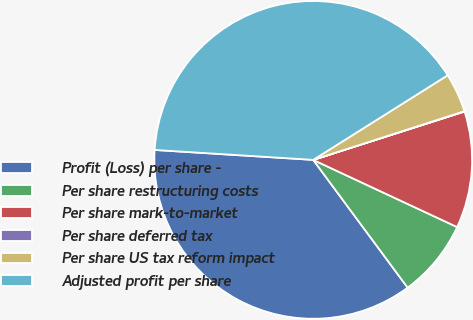<chart> <loc_0><loc_0><loc_500><loc_500><pie_chart><fcel>Profit (Loss) per share -<fcel>Per share restructuring costs<fcel>Per share mark-to-market<fcel>Per share deferred tax<fcel>Per share US tax reform impact<fcel>Adjusted profit per share<nl><fcel>36.13%<fcel>7.92%<fcel>11.87%<fcel>0.04%<fcel>3.98%<fcel>40.07%<nl></chart> 